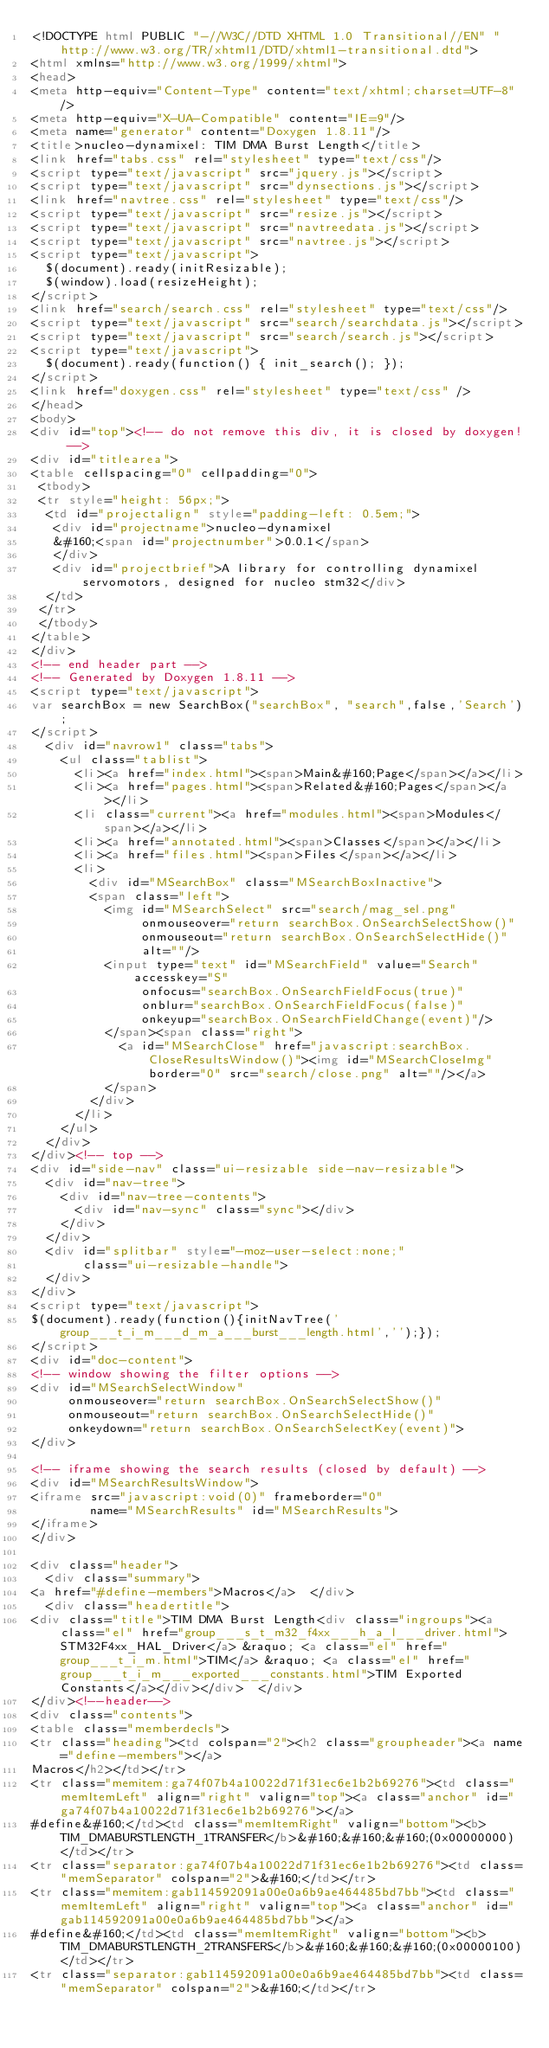Convert code to text. <code><loc_0><loc_0><loc_500><loc_500><_HTML_><!DOCTYPE html PUBLIC "-//W3C//DTD XHTML 1.0 Transitional//EN" "http://www.w3.org/TR/xhtml1/DTD/xhtml1-transitional.dtd">
<html xmlns="http://www.w3.org/1999/xhtml">
<head>
<meta http-equiv="Content-Type" content="text/xhtml;charset=UTF-8"/>
<meta http-equiv="X-UA-Compatible" content="IE=9"/>
<meta name="generator" content="Doxygen 1.8.11"/>
<title>nucleo-dynamixel: TIM DMA Burst Length</title>
<link href="tabs.css" rel="stylesheet" type="text/css"/>
<script type="text/javascript" src="jquery.js"></script>
<script type="text/javascript" src="dynsections.js"></script>
<link href="navtree.css" rel="stylesheet" type="text/css"/>
<script type="text/javascript" src="resize.js"></script>
<script type="text/javascript" src="navtreedata.js"></script>
<script type="text/javascript" src="navtree.js"></script>
<script type="text/javascript">
  $(document).ready(initResizable);
  $(window).load(resizeHeight);
</script>
<link href="search/search.css" rel="stylesheet" type="text/css"/>
<script type="text/javascript" src="search/searchdata.js"></script>
<script type="text/javascript" src="search/search.js"></script>
<script type="text/javascript">
  $(document).ready(function() { init_search(); });
</script>
<link href="doxygen.css" rel="stylesheet" type="text/css" />
</head>
<body>
<div id="top"><!-- do not remove this div, it is closed by doxygen! -->
<div id="titlearea">
<table cellspacing="0" cellpadding="0">
 <tbody>
 <tr style="height: 56px;">
  <td id="projectalign" style="padding-left: 0.5em;">
   <div id="projectname">nucleo-dynamixel
   &#160;<span id="projectnumber">0.0.1</span>
   </div>
   <div id="projectbrief">A library for controlling dynamixel servomotors, designed for nucleo stm32</div>
  </td>
 </tr>
 </tbody>
</table>
</div>
<!-- end header part -->
<!-- Generated by Doxygen 1.8.11 -->
<script type="text/javascript">
var searchBox = new SearchBox("searchBox", "search",false,'Search');
</script>
  <div id="navrow1" class="tabs">
    <ul class="tablist">
      <li><a href="index.html"><span>Main&#160;Page</span></a></li>
      <li><a href="pages.html"><span>Related&#160;Pages</span></a></li>
      <li class="current"><a href="modules.html"><span>Modules</span></a></li>
      <li><a href="annotated.html"><span>Classes</span></a></li>
      <li><a href="files.html"><span>Files</span></a></li>
      <li>
        <div id="MSearchBox" class="MSearchBoxInactive">
        <span class="left">
          <img id="MSearchSelect" src="search/mag_sel.png"
               onmouseover="return searchBox.OnSearchSelectShow()"
               onmouseout="return searchBox.OnSearchSelectHide()"
               alt=""/>
          <input type="text" id="MSearchField" value="Search" accesskey="S"
               onfocus="searchBox.OnSearchFieldFocus(true)" 
               onblur="searchBox.OnSearchFieldFocus(false)" 
               onkeyup="searchBox.OnSearchFieldChange(event)"/>
          </span><span class="right">
            <a id="MSearchClose" href="javascript:searchBox.CloseResultsWindow()"><img id="MSearchCloseImg" border="0" src="search/close.png" alt=""/></a>
          </span>
        </div>
      </li>
    </ul>
  </div>
</div><!-- top -->
<div id="side-nav" class="ui-resizable side-nav-resizable">
  <div id="nav-tree">
    <div id="nav-tree-contents">
      <div id="nav-sync" class="sync"></div>
    </div>
  </div>
  <div id="splitbar" style="-moz-user-select:none;" 
       class="ui-resizable-handle">
  </div>
</div>
<script type="text/javascript">
$(document).ready(function(){initNavTree('group___t_i_m___d_m_a___burst___length.html','');});
</script>
<div id="doc-content">
<!-- window showing the filter options -->
<div id="MSearchSelectWindow"
     onmouseover="return searchBox.OnSearchSelectShow()"
     onmouseout="return searchBox.OnSearchSelectHide()"
     onkeydown="return searchBox.OnSearchSelectKey(event)">
</div>

<!-- iframe showing the search results (closed by default) -->
<div id="MSearchResultsWindow">
<iframe src="javascript:void(0)" frameborder="0" 
        name="MSearchResults" id="MSearchResults">
</iframe>
</div>

<div class="header">
  <div class="summary">
<a href="#define-members">Macros</a>  </div>
  <div class="headertitle">
<div class="title">TIM DMA Burst Length<div class="ingroups"><a class="el" href="group___s_t_m32_f4xx___h_a_l___driver.html">STM32F4xx_HAL_Driver</a> &raquo; <a class="el" href="group___t_i_m.html">TIM</a> &raquo; <a class="el" href="group___t_i_m___exported___constants.html">TIM Exported Constants</a></div></div>  </div>
</div><!--header-->
<div class="contents">
<table class="memberdecls">
<tr class="heading"><td colspan="2"><h2 class="groupheader"><a name="define-members"></a>
Macros</h2></td></tr>
<tr class="memitem:ga74f07b4a10022d71f31ec6e1b2b69276"><td class="memItemLeft" align="right" valign="top"><a class="anchor" id="ga74f07b4a10022d71f31ec6e1b2b69276"></a>
#define&#160;</td><td class="memItemRight" valign="bottom"><b>TIM_DMABURSTLENGTH_1TRANSFER</b>&#160;&#160;&#160;(0x00000000)</td></tr>
<tr class="separator:ga74f07b4a10022d71f31ec6e1b2b69276"><td class="memSeparator" colspan="2">&#160;</td></tr>
<tr class="memitem:gab114592091a00e0a6b9ae464485bd7bb"><td class="memItemLeft" align="right" valign="top"><a class="anchor" id="gab114592091a00e0a6b9ae464485bd7bb"></a>
#define&#160;</td><td class="memItemRight" valign="bottom"><b>TIM_DMABURSTLENGTH_2TRANSFERS</b>&#160;&#160;&#160;(0x00000100)</td></tr>
<tr class="separator:gab114592091a00e0a6b9ae464485bd7bb"><td class="memSeparator" colspan="2">&#160;</td></tr></code> 